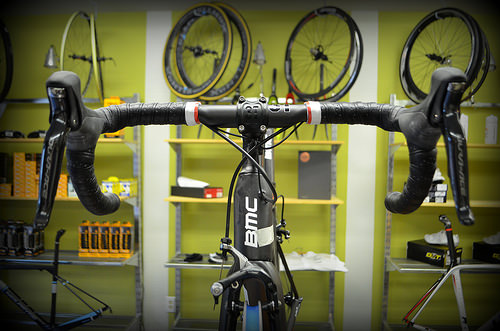<image>
Is there a wheel on the cupboard? Yes. Looking at the image, I can see the wheel is positioned on top of the cupboard, with the cupboard providing support. Is the bike in front of the shelf? Yes. The bike is positioned in front of the shelf, appearing closer to the camera viewpoint. 